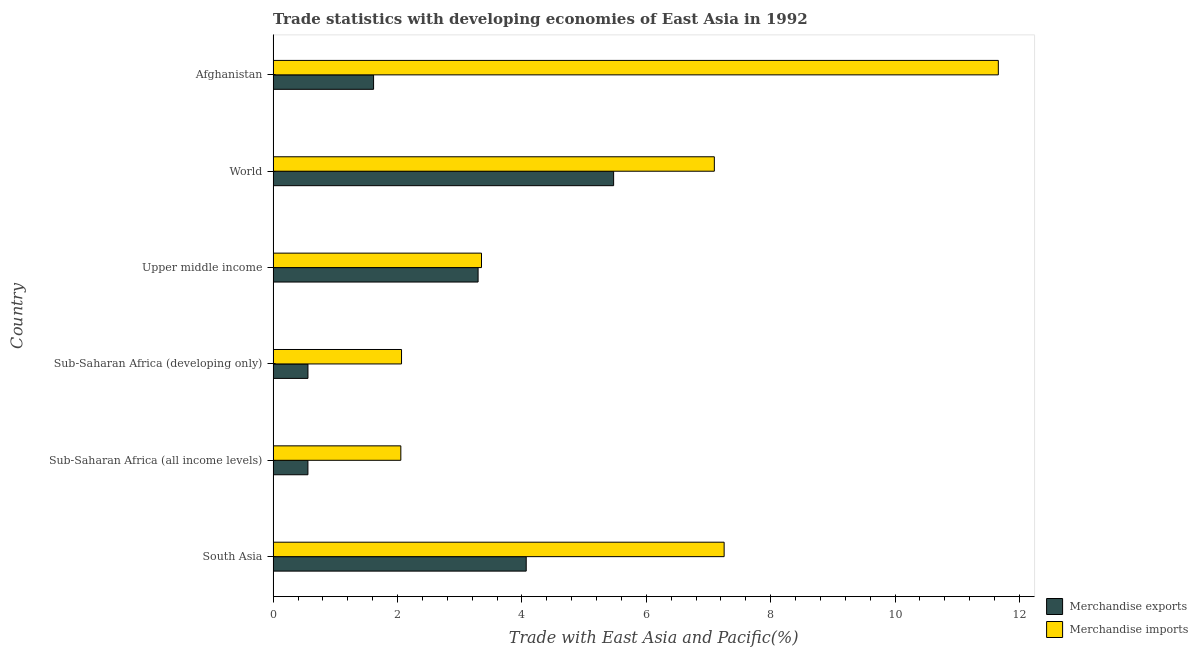Are the number of bars per tick equal to the number of legend labels?
Your response must be concise. Yes. What is the label of the 6th group of bars from the top?
Your answer should be compact. South Asia. In how many cases, is the number of bars for a given country not equal to the number of legend labels?
Your answer should be very brief. 0. What is the merchandise imports in World?
Offer a very short reply. 7.09. Across all countries, what is the maximum merchandise imports?
Your response must be concise. 11.66. Across all countries, what is the minimum merchandise imports?
Your answer should be compact. 2.05. In which country was the merchandise imports minimum?
Make the answer very short. Sub-Saharan Africa (all income levels). What is the total merchandise exports in the graph?
Provide a succinct answer. 15.58. What is the difference between the merchandise exports in Sub-Saharan Africa (all income levels) and that in Upper middle income?
Provide a succinct answer. -2.74. What is the difference between the merchandise imports in World and the merchandise exports in Afghanistan?
Provide a short and direct response. 5.48. What is the average merchandise exports per country?
Give a very brief answer. 2.6. What is the difference between the merchandise imports and merchandise exports in World?
Provide a succinct answer. 1.62. In how many countries, is the merchandise imports greater than 2.8 %?
Offer a terse response. 4. What is the ratio of the merchandise imports in South Asia to that in Upper middle income?
Provide a succinct answer. 2.16. Is the merchandise imports in Sub-Saharan Africa (all income levels) less than that in World?
Make the answer very short. Yes. What is the difference between the highest and the second highest merchandise exports?
Ensure brevity in your answer.  1.41. What is the difference between the highest and the lowest merchandise imports?
Keep it short and to the point. 9.61. Is the sum of the merchandise imports in Sub-Saharan Africa (all income levels) and Upper middle income greater than the maximum merchandise exports across all countries?
Make the answer very short. No. What is the difference between two consecutive major ticks on the X-axis?
Ensure brevity in your answer.  2. Are the values on the major ticks of X-axis written in scientific E-notation?
Keep it short and to the point. No. What is the title of the graph?
Give a very brief answer. Trade statistics with developing economies of East Asia in 1992. What is the label or title of the X-axis?
Your answer should be very brief. Trade with East Asia and Pacific(%). What is the label or title of the Y-axis?
Ensure brevity in your answer.  Country. What is the Trade with East Asia and Pacific(%) of Merchandise exports in South Asia?
Provide a short and direct response. 4.07. What is the Trade with East Asia and Pacific(%) in Merchandise imports in South Asia?
Give a very brief answer. 7.25. What is the Trade with East Asia and Pacific(%) of Merchandise exports in Sub-Saharan Africa (all income levels)?
Give a very brief answer. 0.56. What is the Trade with East Asia and Pacific(%) in Merchandise imports in Sub-Saharan Africa (all income levels)?
Give a very brief answer. 2.05. What is the Trade with East Asia and Pacific(%) of Merchandise exports in Sub-Saharan Africa (developing only)?
Your answer should be very brief. 0.56. What is the Trade with East Asia and Pacific(%) in Merchandise imports in Sub-Saharan Africa (developing only)?
Your response must be concise. 2.06. What is the Trade with East Asia and Pacific(%) in Merchandise exports in Upper middle income?
Provide a short and direct response. 3.3. What is the Trade with East Asia and Pacific(%) of Merchandise imports in Upper middle income?
Your answer should be compact. 3.35. What is the Trade with East Asia and Pacific(%) of Merchandise exports in World?
Make the answer very short. 5.48. What is the Trade with East Asia and Pacific(%) in Merchandise imports in World?
Provide a short and direct response. 7.09. What is the Trade with East Asia and Pacific(%) of Merchandise exports in Afghanistan?
Give a very brief answer. 1.62. What is the Trade with East Asia and Pacific(%) in Merchandise imports in Afghanistan?
Provide a short and direct response. 11.66. Across all countries, what is the maximum Trade with East Asia and Pacific(%) of Merchandise exports?
Offer a very short reply. 5.48. Across all countries, what is the maximum Trade with East Asia and Pacific(%) of Merchandise imports?
Your answer should be very brief. 11.66. Across all countries, what is the minimum Trade with East Asia and Pacific(%) of Merchandise exports?
Your answer should be very brief. 0.56. Across all countries, what is the minimum Trade with East Asia and Pacific(%) in Merchandise imports?
Provide a succinct answer. 2.05. What is the total Trade with East Asia and Pacific(%) in Merchandise exports in the graph?
Make the answer very short. 15.58. What is the total Trade with East Asia and Pacific(%) of Merchandise imports in the graph?
Make the answer very short. 33.48. What is the difference between the Trade with East Asia and Pacific(%) in Merchandise exports in South Asia and that in Sub-Saharan Africa (all income levels)?
Give a very brief answer. 3.51. What is the difference between the Trade with East Asia and Pacific(%) in Merchandise imports in South Asia and that in Sub-Saharan Africa (all income levels)?
Keep it short and to the point. 5.2. What is the difference between the Trade with East Asia and Pacific(%) of Merchandise exports in South Asia and that in Sub-Saharan Africa (developing only)?
Your answer should be very brief. 3.51. What is the difference between the Trade with East Asia and Pacific(%) of Merchandise imports in South Asia and that in Sub-Saharan Africa (developing only)?
Your response must be concise. 5.19. What is the difference between the Trade with East Asia and Pacific(%) in Merchandise exports in South Asia and that in Upper middle income?
Keep it short and to the point. 0.77. What is the difference between the Trade with East Asia and Pacific(%) in Merchandise imports in South Asia and that in Upper middle income?
Keep it short and to the point. 3.9. What is the difference between the Trade with East Asia and Pacific(%) in Merchandise exports in South Asia and that in World?
Your response must be concise. -1.41. What is the difference between the Trade with East Asia and Pacific(%) in Merchandise imports in South Asia and that in World?
Your answer should be very brief. 0.16. What is the difference between the Trade with East Asia and Pacific(%) in Merchandise exports in South Asia and that in Afghanistan?
Provide a succinct answer. 2.45. What is the difference between the Trade with East Asia and Pacific(%) of Merchandise imports in South Asia and that in Afghanistan?
Provide a short and direct response. -4.41. What is the difference between the Trade with East Asia and Pacific(%) of Merchandise exports in Sub-Saharan Africa (all income levels) and that in Sub-Saharan Africa (developing only)?
Make the answer very short. -0. What is the difference between the Trade with East Asia and Pacific(%) in Merchandise imports in Sub-Saharan Africa (all income levels) and that in Sub-Saharan Africa (developing only)?
Provide a short and direct response. -0.01. What is the difference between the Trade with East Asia and Pacific(%) of Merchandise exports in Sub-Saharan Africa (all income levels) and that in Upper middle income?
Offer a very short reply. -2.74. What is the difference between the Trade with East Asia and Pacific(%) of Merchandise imports in Sub-Saharan Africa (all income levels) and that in Upper middle income?
Offer a terse response. -1.3. What is the difference between the Trade with East Asia and Pacific(%) of Merchandise exports in Sub-Saharan Africa (all income levels) and that in World?
Offer a terse response. -4.92. What is the difference between the Trade with East Asia and Pacific(%) of Merchandise imports in Sub-Saharan Africa (all income levels) and that in World?
Your answer should be compact. -5.04. What is the difference between the Trade with East Asia and Pacific(%) of Merchandise exports in Sub-Saharan Africa (all income levels) and that in Afghanistan?
Offer a very short reply. -1.06. What is the difference between the Trade with East Asia and Pacific(%) in Merchandise imports in Sub-Saharan Africa (all income levels) and that in Afghanistan?
Your response must be concise. -9.61. What is the difference between the Trade with East Asia and Pacific(%) of Merchandise exports in Sub-Saharan Africa (developing only) and that in Upper middle income?
Provide a succinct answer. -2.74. What is the difference between the Trade with East Asia and Pacific(%) in Merchandise imports in Sub-Saharan Africa (developing only) and that in Upper middle income?
Your answer should be compact. -1.29. What is the difference between the Trade with East Asia and Pacific(%) of Merchandise exports in Sub-Saharan Africa (developing only) and that in World?
Your answer should be very brief. -4.91. What is the difference between the Trade with East Asia and Pacific(%) of Merchandise imports in Sub-Saharan Africa (developing only) and that in World?
Offer a terse response. -5.03. What is the difference between the Trade with East Asia and Pacific(%) in Merchandise exports in Sub-Saharan Africa (developing only) and that in Afghanistan?
Provide a short and direct response. -1.06. What is the difference between the Trade with East Asia and Pacific(%) in Merchandise imports in Sub-Saharan Africa (developing only) and that in Afghanistan?
Offer a very short reply. -9.6. What is the difference between the Trade with East Asia and Pacific(%) of Merchandise exports in Upper middle income and that in World?
Keep it short and to the point. -2.18. What is the difference between the Trade with East Asia and Pacific(%) in Merchandise imports in Upper middle income and that in World?
Provide a short and direct response. -3.74. What is the difference between the Trade with East Asia and Pacific(%) in Merchandise exports in Upper middle income and that in Afghanistan?
Provide a short and direct response. 1.68. What is the difference between the Trade with East Asia and Pacific(%) in Merchandise imports in Upper middle income and that in Afghanistan?
Ensure brevity in your answer.  -8.31. What is the difference between the Trade with East Asia and Pacific(%) in Merchandise exports in World and that in Afghanistan?
Give a very brief answer. 3.86. What is the difference between the Trade with East Asia and Pacific(%) in Merchandise imports in World and that in Afghanistan?
Offer a very short reply. -4.57. What is the difference between the Trade with East Asia and Pacific(%) in Merchandise exports in South Asia and the Trade with East Asia and Pacific(%) in Merchandise imports in Sub-Saharan Africa (all income levels)?
Offer a very short reply. 2.02. What is the difference between the Trade with East Asia and Pacific(%) in Merchandise exports in South Asia and the Trade with East Asia and Pacific(%) in Merchandise imports in Sub-Saharan Africa (developing only)?
Give a very brief answer. 2.01. What is the difference between the Trade with East Asia and Pacific(%) of Merchandise exports in South Asia and the Trade with East Asia and Pacific(%) of Merchandise imports in Upper middle income?
Provide a succinct answer. 0.72. What is the difference between the Trade with East Asia and Pacific(%) in Merchandise exports in South Asia and the Trade with East Asia and Pacific(%) in Merchandise imports in World?
Ensure brevity in your answer.  -3.02. What is the difference between the Trade with East Asia and Pacific(%) of Merchandise exports in South Asia and the Trade with East Asia and Pacific(%) of Merchandise imports in Afghanistan?
Ensure brevity in your answer.  -7.59. What is the difference between the Trade with East Asia and Pacific(%) in Merchandise exports in Sub-Saharan Africa (all income levels) and the Trade with East Asia and Pacific(%) in Merchandise imports in Sub-Saharan Africa (developing only)?
Offer a very short reply. -1.51. What is the difference between the Trade with East Asia and Pacific(%) in Merchandise exports in Sub-Saharan Africa (all income levels) and the Trade with East Asia and Pacific(%) in Merchandise imports in Upper middle income?
Offer a very short reply. -2.79. What is the difference between the Trade with East Asia and Pacific(%) of Merchandise exports in Sub-Saharan Africa (all income levels) and the Trade with East Asia and Pacific(%) of Merchandise imports in World?
Keep it short and to the point. -6.53. What is the difference between the Trade with East Asia and Pacific(%) in Merchandise exports in Sub-Saharan Africa (all income levels) and the Trade with East Asia and Pacific(%) in Merchandise imports in Afghanistan?
Offer a terse response. -11.1. What is the difference between the Trade with East Asia and Pacific(%) of Merchandise exports in Sub-Saharan Africa (developing only) and the Trade with East Asia and Pacific(%) of Merchandise imports in Upper middle income?
Keep it short and to the point. -2.79. What is the difference between the Trade with East Asia and Pacific(%) in Merchandise exports in Sub-Saharan Africa (developing only) and the Trade with East Asia and Pacific(%) in Merchandise imports in World?
Provide a short and direct response. -6.53. What is the difference between the Trade with East Asia and Pacific(%) in Merchandise exports in Sub-Saharan Africa (developing only) and the Trade with East Asia and Pacific(%) in Merchandise imports in Afghanistan?
Your answer should be very brief. -11.1. What is the difference between the Trade with East Asia and Pacific(%) of Merchandise exports in Upper middle income and the Trade with East Asia and Pacific(%) of Merchandise imports in World?
Make the answer very short. -3.8. What is the difference between the Trade with East Asia and Pacific(%) of Merchandise exports in Upper middle income and the Trade with East Asia and Pacific(%) of Merchandise imports in Afghanistan?
Your response must be concise. -8.37. What is the difference between the Trade with East Asia and Pacific(%) of Merchandise exports in World and the Trade with East Asia and Pacific(%) of Merchandise imports in Afghanistan?
Make the answer very short. -6.19. What is the average Trade with East Asia and Pacific(%) in Merchandise exports per country?
Make the answer very short. 2.6. What is the average Trade with East Asia and Pacific(%) in Merchandise imports per country?
Provide a short and direct response. 5.58. What is the difference between the Trade with East Asia and Pacific(%) of Merchandise exports and Trade with East Asia and Pacific(%) of Merchandise imports in South Asia?
Provide a succinct answer. -3.18. What is the difference between the Trade with East Asia and Pacific(%) in Merchandise exports and Trade with East Asia and Pacific(%) in Merchandise imports in Sub-Saharan Africa (all income levels)?
Provide a short and direct response. -1.49. What is the difference between the Trade with East Asia and Pacific(%) in Merchandise exports and Trade with East Asia and Pacific(%) in Merchandise imports in Sub-Saharan Africa (developing only)?
Give a very brief answer. -1.5. What is the difference between the Trade with East Asia and Pacific(%) in Merchandise exports and Trade with East Asia and Pacific(%) in Merchandise imports in Upper middle income?
Make the answer very short. -0.05. What is the difference between the Trade with East Asia and Pacific(%) in Merchandise exports and Trade with East Asia and Pacific(%) in Merchandise imports in World?
Keep it short and to the point. -1.62. What is the difference between the Trade with East Asia and Pacific(%) in Merchandise exports and Trade with East Asia and Pacific(%) in Merchandise imports in Afghanistan?
Make the answer very short. -10.05. What is the ratio of the Trade with East Asia and Pacific(%) of Merchandise exports in South Asia to that in Sub-Saharan Africa (all income levels)?
Ensure brevity in your answer.  7.27. What is the ratio of the Trade with East Asia and Pacific(%) of Merchandise imports in South Asia to that in Sub-Saharan Africa (all income levels)?
Keep it short and to the point. 3.53. What is the ratio of the Trade with East Asia and Pacific(%) in Merchandise exports in South Asia to that in Sub-Saharan Africa (developing only)?
Your answer should be compact. 7.27. What is the ratio of the Trade with East Asia and Pacific(%) in Merchandise imports in South Asia to that in Sub-Saharan Africa (developing only)?
Ensure brevity in your answer.  3.51. What is the ratio of the Trade with East Asia and Pacific(%) of Merchandise exports in South Asia to that in Upper middle income?
Provide a succinct answer. 1.23. What is the ratio of the Trade with East Asia and Pacific(%) of Merchandise imports in South Asia to that in Upper middle income?
Your answer should be very brief. 2.16. What is the ratio of the Trade with East Asia and Pacific(%) in Merchandise exports in South Asia to that in World?
Make the answer very short. 0.74. What is the ratio of the Trade with East Asia and Pacific(%) of Merchandise imports in South Asia to that in World?
Provide a succinct answer. 1.02. What is the ratio of the Trade with East Asia and Pacific(%) in Merchandise exports in South Asia to that in Afghanistan?
Your answer should be compact. 2.52. What is the ratio of the Trade with East Asia and Pacific(%) of Merchandise imports in South Asia to that in Afghanistan?
Provide a short and direct response. 0.62. What is the ratio of the Trade with East Asia and Pacific(%) in Merchandise exports in Sub-Saharan Africa (all income levels) to that in Sub-Saharan Africa (developing only)?
Offer a very short reply. 1. What is the ratio of the Trade with East Asia and Pacific(%) of Merchandise imports in Sub-Saharan Africa (all income levels) to that in Sub-Saharan Africa (developing only)?
Give a very brief answer. 0.99. What is the ratio of the Trade with East Asia and Pacific(%) of Merchandise exports in Sub-Saharan Africa (all income levels) to that in Upper middle income?
Make the answer very short. 0.17. What is the ratio of the Trade with East Asia and Pacific(%) of Merchandise imports in Sub-Saharan Africa (all income levels) to that in Upper middle income?
Make the answer very short. 0.61. What is the ratio of the Trade with East Asia and Pacific(%) in Merchandise exports in Sub-Saharan Africa (all income levels) to that in World?
Your response must be concise. 0.1. What is the ratio of the Trade with East Asia and Pacific(%) of Merchandise imports in Sub-Saharan Africa (all income levels) to that in World?
Give a very brief answer. 0.29. What is the ratio of the Trade with East Asia and Pacific(%) of Merchandise exports in Sub-Saharan Africa (all income levels) to that in Afghanistan?
Provide a succinct answer. 0.35. What is the ratio of the Trade with East Asia and Pacific(%) of Merchandise imports in Sub-Saharan Africa (all income levels) to that in Afghanistan?
Your answer should be very brief. 0.18. What is the ratio of the Trade with East Asia and Pacific(%) in Merchandise exports in Sub-Saharan Africa (developing only) to that in Upper middle income?
Offer a terse response. 0.17. What is the ratio of the Trade with East Asia and Pacific(%) in Merchandise imports in Sub-Saharan Africa (developing only) to that in Upper middle income?
Ensure brevity in your answer.  0.62. What is the ratio of the Trade with East Asia and Pacific(%) in Merchandise exports in Sub-Saharan Africa (developing only) to that in World?
Offer a terse response. 0.1. What is the ratio of the Trade with East Asia and Pacific(%) in Merchandise imports in Sub-Saharan Africa (developing only) to that in World?
Offer a very short reply. 0.29. What is the ratio of the Trade with East Asia and Pacific(%) of Merchandise exports in Sub-Saharan Africa (developing only) to that in Afghanistan?
Make the answer very short. 0.35. What is the ratio of the Trade with East Asia and Pacific(%) in Merchandise imports in Sub-Saharan Africa (developing only) to that in Afghanistan?
Offer a very short reply. 0.18. What is the ratio of the Trade with East Asia and Pacific(%) of Merchandise exports in Upper middle income to that in World?
Give a very brief answer. 0.6. What is the ratio of the Trade with East Asia and Pacific(%) in Merchandise imports in Upper middle income to that in World?
Provide a succinct answer. 0.47. What is the ratio of the Trade with East Asia and Pacific(%) of Merchandise exports in Upper middle income to that in Afghanistan?
Your answer should be very brief. 2.04. What is the ratio of the Trade with East Asia and Pacific(%) in Merchandise imports in Upper middle income to that in Afghanistan?
Provide a short and direct response. 0.29. What is the ratio of the Trade with East Asia and Pacific(%) of Merchandise exports in World to that in Afghanistan?
Your answer should be very brief. 3.39. What is the ratio of the Trade with East Asia and Pacific(%) in Merchandise imports in World to that in Afghanistan?
Your answer should be compact. 0.61. What is the difference between the highest and the second highest Trade with East Asia and Pacific(%) of Merchandise exports?
Offer a very short reply. 1.41. What is the difference between the highest and the second highest Trade with East Asia and Pacific(%) of Merchandise imports?
Ensure brevity in your answer.  4.41. What is the difference between the highest and the lowest Trade with East Asia and Pacific(%) in Merchandise exports?
Offer a very short reply. 4.92. What is the difference between the highest and the lowest Trade with East Asia and Pacific(%) in Merchandise imports?
Keep it short and to the point. 9.61. 